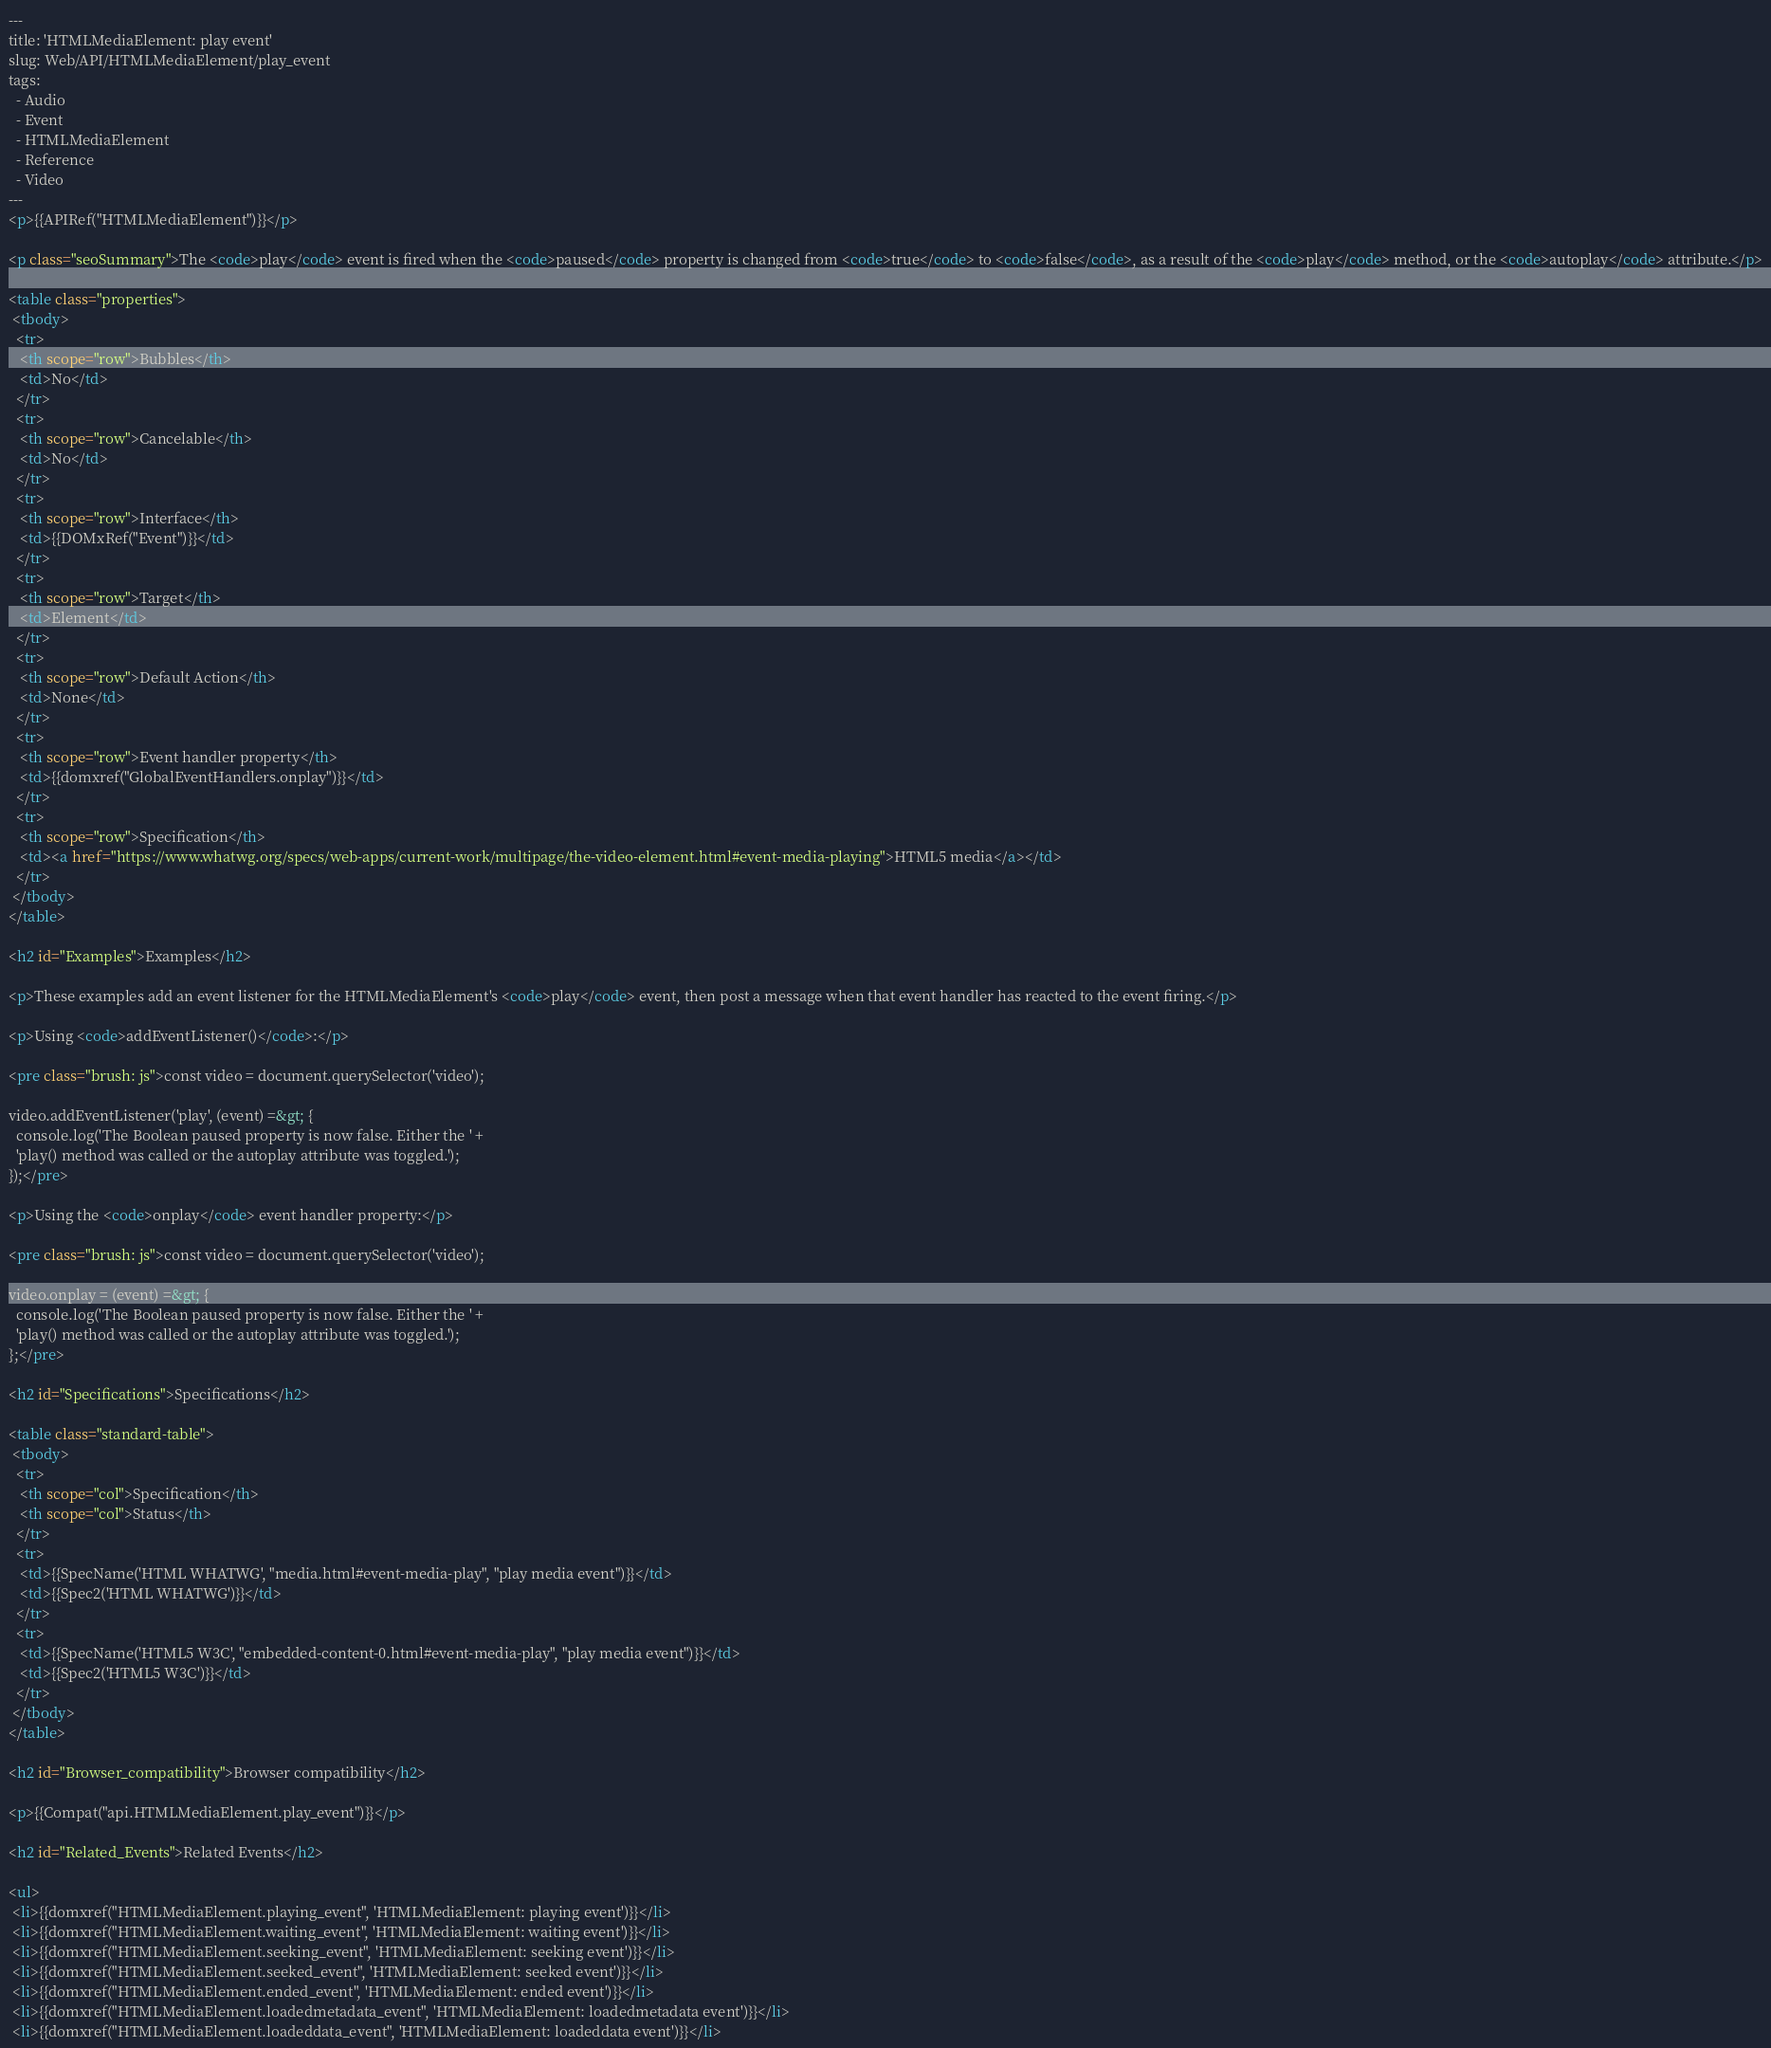<code> <loc_0><loc_0><loc_500><loc_500><_HTML_>---
title: 'HTMLMediaElement: play event'
slug: Web/API/HTMLMediaElement/play_event
tags:
  - Audio
  - Event
  - HTMLMediaElement
  - Reference
  - Video
---
<p>{{APIRef("HTMLMediaElement")}}</p>

<p class="seoSummary">The <code>play</code> event is fired when the <code>paused</code> property is changed from <code>true</code> to <code>false</code>, as a result of the <code>play</code> method, or the <code>autoplay</code> attribute.</p>

<table class="properties">
 <tbody>
  <tr>
   <th scope="row">Bubbles</th>
   <td>No</td>
  </tr>
  <tr>
   <th scope="row">Cancelable</th>
   <td>No</td>
  </tr>
  <tr>
   <th scope="row">Interface</th>
   <td>{{DOMxRef("Event")}}</td>
  </tr>
  <tr>
   <th scope="row">Target</th>
   <td>Element</td>
  </tr>
  <tr>
   <th scope="row">Default Action</th>
   <td>None</td>
  </tr>
  <tr>
   <th scope="row">Event handler property</th>
   <td>{{domxref("GlobalEventHandlers.onplay")}}</td>
  </tr>
  <tr>
   <th scope="row">Specification</th>
   <td><a href="https://www.whatwg.org/specs/web-apps/current-work/multipage/the-video-element.html#event-media-playing">HTML5 media</a></td>
  </tr>
 </tbody>
</table>

<h2 id="Examples">Examples</h2>

<p>These examples add an event listener for the HTMLMediaElement's <code>play</code> event, then post a message when that event handler has reacted to the event firing.</p>

<p>Using <code>addEventListener()</code>:</p>

<pre class="brush: js">const video = document.querySelector('video');

video.addEventListener('play', (event) =&gt; {
  console.log('The Boolean paused property is now false. Either the ' +
  'play() method was called or the autoplay attribute was toggled.');
});</pre>

<p>Using the <code>onplay</code> event handler property:</p>

<pre class="brush: js">const video = document.querySelector('video');

video.onplay = (event) =&gt; {
  console.log('The Boolean paused property is now false. Either the ' +
  'play() method was called or the autoplay attribute was toggled.');
};</pre>

<h2 id="Specifications">Specifications</h2>

<table class="standard-table">
 <tbody>
  <tr>
   <th scope="col">Specification</th>
   <th scope="col">Status</th>
  </tr>
  <tr>
   <td>{{SpecName('HTML WHATWG', "media.html#event-media-play", "play media event")}}</td>
   <td>{{Spec2('HTML WHATWG')}}</td>
  </tr>
  <tr>
   <td>{{SpecName('HTML5 W3C', "embedded-content-0.html#event-media-play", "play media event")}}</td>
   <td>{{Spec2('HTML5 W3C')}}</td>
  </tr>
 </tbody>
</table>

<h2 id="Browser_compatibility">Browser compatibility</h2>

<p>{{Compat("api.HTMLMediaElement.play_event")}}</p>

<h2 id="Related_Events">Related Events</h2>

<ul>
 <li>{{domxref("HTMLMediaElement.playing_event", 'HTMLMediaElement: playing event')}}</li>
 <li>{{domxref("HTMLMediaElement.waiting_event", 'HTMLMediaElement: waiting event')}}</li>
 <li>{{domxref("HTMLMediaElement.seeking_event", 'HTMLMediaElement: seeking event')}}</li>
 <li>{{domxref("HTMLMediaElement.seeked_event", 'HTMLMediaElement: seeked event')}}</li>
 <li>{{domxref("HTMLMediaElement.ended_event", 'HTMLMediaElement: ended event')}}</li>
 <li>{{domxref("HTMLMediaElement.loadedmetadata_event", 'HTMLMediaElement: loadedmetadata event')}}</li>
 <li>{{domxref("HTMLMediaElement.loadeddata_event", 'HTMLMediaElement: loadeddata event')}}</li></code> 